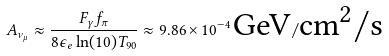Convert formula to latex. <formula><loc_0><loc_0><loc_500><loc_500>A _ { \nu _ { \mu } } \approx \frac { F _ { \gamma } f _ { \pi } } { 8 \epsilon _ { e } \ln ( 1 0 ) T _ { 9 0 } } \approx 9 . 8 6 \times 1 0 ^ { - 4 } \, \text {GeV} / \text {cm$^{2}/$s}</formula> 